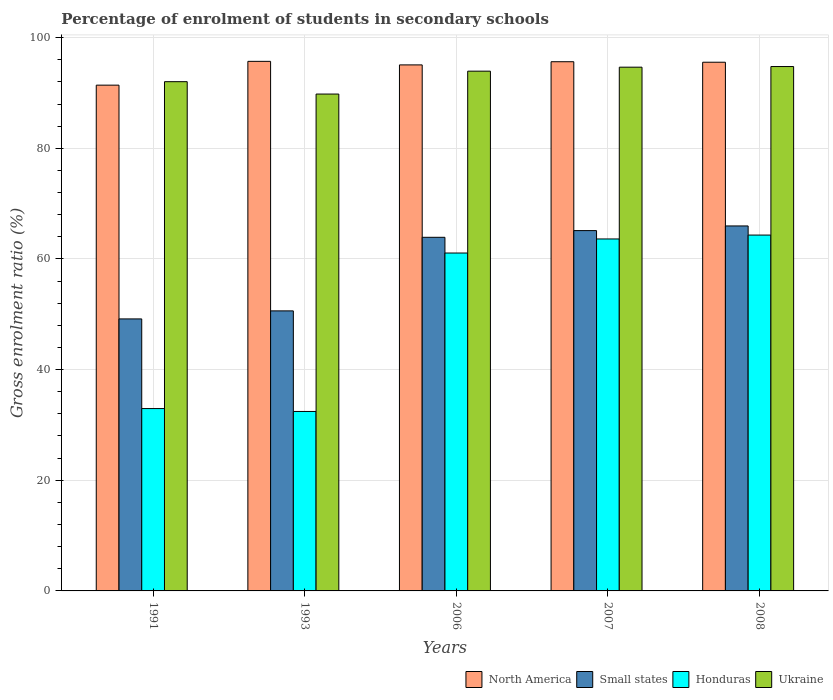How many bars are there on the 5th tick from the left?
Give a very brief answer. 4. What is the percentage of students enrolled in secondary schools in Ukraine in 2007?
Your answer should be compact. 94.66. Across all years, what is the maximum percentage of students enrolled in secondary schools in Small states?
Keep it short and to the point. 65.96. Across all years, what is the minimum percentage of students enrolled in secondary schools in Ukraine?
Keep it short and to the point. 89.8. In which year was the percentage of students enrolled in secondary schools in Small states maximum?
Keep it short and to the point. 2008. In which year was the percentage of students enrolled in secondary schools in North America minimum?
Provide a short and direct response. 1991. What is the total percentage of students enrolled in secondary schools in North America in the graph?
Provide a short and direct response. 473.38. What is the difference between the percentage of students enrolled in secondary schools in Small states in 2006 and that in 2007?
Offer a very short reply. -1.21. What is the difference between the percentage of students enrolled in secondary schools in Honduras in 2007 and the percentage of students enrolled in secondary schools in Ukraine in 2006?
Your answer should be compact. -30.33. What is the average percentage of students enrolled in secondary schools in Honduras per year?
Your response must be concise. 50.88. In the year 2006, what is the difference between the percentage of students enrolled in secondary schools in Ukraine and percentage of students enrolled in secondary schools in Small states?
Make the answer very short. 30.03. What is the ratio of the percentage of students enrolled in secondary schools in North America in 1991 to that in 2007?
Your response must be concise. 0.96. Is the percentage of students enrolled in secondary schools in Honduras in 2006 less than that in 2007?
Ensure brevity in your answer.  Yes. Is the difference between the percentage of students enrolled in secondary schools in Ukraine in 2007 and 2008 greater than the difference between the percentage of students enrolled in secondary schools in Small states in 2007 and 2008?
Provide a succinct answer. Yes. What is the difference between the highest and the second highest percentage of students enrolled in secondary schools in North America?
Your answer should be compact. 0.07. What is the difference between the highest and the lowest percentage of students enrolled in secondary schools in Small states?
Give a very brief answer. 16.8. Is it the case that in every year, the sum of the percentage of students enrolled in secondary schools in Honduras and percentage of students enrolled in secondary schools in Small states is greater than the sum of percentage of students enrolled in secondary schools in North America and percentage of students enrolled in secondary schools in Ukraine?
Give a very brief answer. No. What does the 4th bar from the left in 2007 represents?
Provide a short and direct response. Ukraine. What does the 3rd bar from the right in 2007 represents?
Make the answer very short. Small states. What is the difference between two consecutive major ticks on the Y-axis?
Your answer should be very brief. 20. How are the legend labels stacked?
Your answer should be compact. Horizontal. What is the title of the graph?
Ensure brevity in your answer.  Percentage of enrolment of students in secondary schools. What is the label or title of the X-axis?
Offer a very short reply. Years. What is the Gross enrolment ratio (%) of North America in 1991?
Ensure brevity in your answer.  91.41. What is the Gross enrolment ratio (%) in Small states in 1991?
Provide a succinct answer. 49.16. What is the Gross enrolment ratio (%) in Honduras in 1991?
Ensure brevity in your answer.  32.96. What is the Gross enrolment ratio (%) in Ukraine in 1991?
Give a very brief answer. 92.04. What is the Gross enrolment ratio (%) in North America in 1993?
Give a very brief answer. 95.71. What is the Gross enrolment ratio (%) of Small states in 1993?
Provide a succinct answer. 50.61. What is the Gross enrolment ratio (%) in Honduras in 1993?
Provide a succinct answer. 32.44. What is the Gross enrolment ratio (%) of Ukraine in 1993?
Provide a succinct answer. 89.8. What is the Gross enrolment ratio (%) of North America in 2006?
Provide a succinct answer. 95.07. What is the Gross enrolment ratio (%) in Small states in 2006?
Your answer should be compact. 63.91. What is the Gross enrolment ratio (%) in Honduras in 2006?
Offer a very short reply. 61.07. What is the Gross enrolment ratio (%) of Ukraine in 2006?
Keep it short and to the point. 93.94. What is the Gross enrolment ratio (%) in North America in 2007?
Offer a terse response. 95.64. What is the Gross enrolment ratio (%) of Small states in 2007?
Keep it short and to the point. 65.12. What is the Gross enrolment ratio (%) in Honduras in 2007?
Provide a short and direct response. 63.61. What is the Gross enrolment ratio (%) of Ukraine in 2007?
Your answer should be very brief. 94.66. What is the Gross enrolment ratio (%) of North America in 2008?
Keep it short and to the point. 95.55. What is the Gross enrolment ratio (%) of Small states in 2008?
Offer a very short reply. 65.96. What is the Gross enrolment ratio (%) in Honduras in 2008?
Give a very brief answer. 64.31. What is the Gross enrolment ratio (%) of Ukraine in 2008?
Your answer should be very brief. 94.77. Across all years, what is the maximum Gross enrolment ratio (%) of North America?
Provide a succinct answer. 95.71. Across all years, what is the maximum Gross enrolment ratio (%) in Small states?
Make the answer very short. 65.96. Across all years, what is the maximum Gross enrolment ratio (%) in Honduras?
Make the answer very short. 64.31. Across all years, what is the maximum Gross enrolment ratio (%) of Ukraine?
Your answer should be compact. 94.77. Across all years, what is the minimum Gross enrolment ratio (%) of North America?
Make the answer very short. 91.41. Across all years, what is the minimum Gross enrolment ratio (%) in Small states?
Ensure brevity in your answer.  49.16. Across all years, what is the minimum Gross enrolment ratio (%) of Honduras?
Provide a succinct answer. 32.44. Across all years, what is the minimum Gross enrolment ratio (%) in Ukraine?
Give a very brief answer. 89.8. What is the total Gross enrolment ratio (%) in North America in the graph?
Ensure brevity in your answer.  473.38. What is the total Gross enrolment ratio (%) of Small states in the graph?
Provide a succinct answer. 294.77. What is the total Gross enrolment ratio (%) in Honduras in the graph?
Provide a short and direct response. 254.38. What is the total Gross enrolment ratio (%) of Ukraine in the graph?
Your answer should be compact. 465.2. What is the difference between the Gross enrolment ratio (%) in North America in 1991 and that in 1993?
Provide a succinct answer. -4.3. What is the difference between the Gross enrolment ratio (%) in Small states in 1991 and that in 1993?
Make the answer very short. -1.45. What is the difference between the Gross enrolment ratio (%) in Honduras in 1991 and that in 1993?
Provide a short and direct response. 0.52. What is the difference between the Gross enrolment ratio (%) in Ukraine in 1991 and that in 1993?
Your answer should be compact. 2.24. What is the difference between the Gross enrolment ratio (%) in North America in 1991 and that in 2006?
Provide a short and direct response. -3.66. What is the difference between the Gross enrolment ratio (%) of Small states in 1991 and that in 2006?
Ensure brevity in your answer.  -14.75. What is the difference between the Gross enrolment ratio (%) of Honduras in 1991 and that in 2006?
Offer a very short reply. -28.11. What is the difference between the Gross enrolment ratio (%) in Ukraine in 1991 and that in 2006?
Offer a terse response. -1.9. What is the difference between the Gross enrolment ratio (%) in North America in 1991 and that in 2007?
Your answer should be very brief. -4.23. What is the difference between the Gross enrolment ratio (%) in Small states in 1991 and that in 2007?
Give a very brief answer. -15.96. What is the difference between the Gross enrolment ratio (%) in Honduras in 1991 and that in 2007?
Make the answer very short. -30.65. What is the difference between the Gross enrolment ratio (%) of Ukraine in 1991 and that in 2007?
Keep it short and to the point. -2.62. What is the difference between the Gross enrolment ratio (%) of North America in 1991 and that in 2008?
Offer a terse response. -4.14. What is the difference between the Gross enrolment ratio (%) in Small states in 1991 and that in 2008?
Your response must be concise. -16.8. What is the difference between the Gross enrolment ratio (%) of Honduras in 1991 and that in 2008?
Your response must be concise. -31.36. What is the difference between the Gross enrolment ratio (%) of Ukraine in 1991 and that in 2008?
Make the answer very short. -2.74. What is the difference between the Gross enrolment ratio (%) of North America in 1993 and that in 2006?
Provide a succinct answer. 0.64. What is the difference between the Gross enrolment ratio (%) of Small states in 1993 and that in 2006?
Provide a short and direct response. -13.3. What is the difference between the Gross enrolment ratio (%) of Honduras in 1993 and that in 2006?
Your answer should be compact. -28.63. What is the difference between the Gross enrolment ratio (%) in Ukraine in 1993 and that in 2006?
Your answer should be compact. -4.14. What is the difference between the Gross enrolment ratio (%) in North America in 1993 and that in 2007?
Ensure brevity in your answer.  0.07. What is the difference between the Gross enrolment ratio (%) in Small states in 1993 and that in 2007?
Give a very brief answer. -14.51. What is the difference between the Gross enrolment ratio (%) in Honduras in 1993 and that in 2007?
Your answer should be compact. -31.18. What is the difference between the Gross enrolment ratio (%) of Ukraine in 1993 and that in 2007?
Keep it short and to the point. -4.86. What is the difference between the Gross enrolment ratio (%) in North America in 1993 and that in 2008?
Offer a terse response. 0.16. What is the difference between the Gross enrolment ratio (%) of Small states in 1993 and that in 2008?
Provide a succinct answer. -15.35. What is the difference between the Gross enrolment ratio (%) of Honduras in 1993 and that in 2008?
Make the answer very short. -31.88. What is the difference between the Gross enrolment ratio (%) of Ukraine in 1993 and that in 2008?
Make the answer very short. -4.97. What is the difference between the Gross enrolment ratio (%) in North America in 2006 and that in 2007?
Make the answer very short. -0.57. What is the difference between the Gross enrolment ratio (%) in Small states in 2006 and that in 2007?
Give a very brief answer. -1.21. What is the difference between the Gross enrolment ratio (%) in Honduras in 2006 and that in 2007?
Your answer should be very brief. -2.54. What is the difference between the Gross enrolment ratio (%) in Ukraine in 2006 and that in 2007?
Ensure brevity in your answer.  -0.72. What is the difference between the Gross enrolment ratio (%) of North America in 2006 and that in 2008?
Provide a succinct answer. -0.48. What is the difference between the Gross enrolment ratio (%) in Small states in 2006 and that in 2008?
Ensure brevity in your answer.  -2.05. What is the difference between the Gross enrolment ratio (%) of Honduras in 2006 and that in 2008?
Make the answer very short. -3.25. What is the difference between the Gross enrolment ratio (%) of Ukraine in 2006 and that in 2008?
Give a very brief answer. -0.83. What is the difference between the Gross enrolment ratio (%) of North America in 2007 and that in 2008?
Keep it short and to the point. 0.09. What is the difference between the Gross enrolment ratio (%) in Small states in 2007 and that in 2008?
Ensure brevity in your answer.  -0.84. What is the difference between the Gross enrolment ratio (%) in Honduras in 2007 and that in 2008?
Keep it short and to the point. -0.7. What is the difference between the Gross enrolment ratio (%) in Ukraine in 2007 and that in 2008?
Your response must be concise. -0.12. What is the difference between the Gross enrolment ratio (%) of North America in 1991 and the Gross enrolment ratio (%) of Small states in 1993?
Make the answer very short. 40.8. What is the difference between the Gross enrolment ratio (%) of North America in 1991 and the Gross enrolment ratio (%) of Honduras in 1993?
Make the answer very short. 58.97. What is the difference between the Gross enrolment ratio (%) in North America in 1991 and the Gross enrolment ratio (%) in Ukraine in 1993?
Give a very brief answer. 1.61. What is the difference between the Gross enrolment ratio (%) in Small states in 1991 and the Gross enrolment ratio (%) in Honduras in 1993?
Make the answer very short. 16.73. What is the difference between the Gross enrolment ratio (%) in Small states in 1991 and the Gross enrolment ratio (%) in Ukraine in 1993?
Your response must be concise. -40.64. What is the difference between the Gross enrolment ratio (%) of Honduras in 1991 and the Gross enrolment ratio (%) of Ukraine in 1993?
Offer a very short reply. -56.84. What is the difference between the Gross enrolment ratio (%) in North America in 1991 and the Gross enrolment ratio (%) in Small states in 2006?
Your answer should be very brief. 27.5. What is the difference between the Gross enrolment ratio (%) in North America in 1991 and the Gross enrolment ratio (%) in Honduras in 2006?
Provide a short and direct response. 30.34. What is the difference between the Gross enrolment ratio (%) in North America in 1991 and the Gross enrolment ratio (%) in Ukraine in 2006?
Ensure brevity in your answer.  -2.53. What is the difference between the Gross enrolment ratio (%) in Small states in 1991 and the Gross enrolment ratio (%) in Honduras in 2006?
Your answer should be compact. -11.91. What is the difference between the Gross enrolment ratio (%) of Small states in 1991 and the Gross enrolment ratio (%) of Ukraine in 2006?
Ensure brevity in your answer.  -44.78. What is the difference between the Gross enrolment ratio (%) in Honduras in 1991 and the Gross enrolment ratio (%) in Ukraine in 2006?
Offer a very short reply. -60.98. What is the difference between the Gross enrolment ratio (%) in North America in 1991 and the Gross enrolment ratio (%) in Small states in 2007?
Ensure brevity in your answer.  26.29. What is the difference between the Gross enrolment ratio (%) in North America in 1991 and the Gross enrolment ratio (%) in Honduras in 2007?
Give a very brief answer. 27.8. What is the difference between the Gross enrolment ratio (%) in North America in 1991 and the Gross enrolment ratio (%) in Ukraine in 2007?
Offer a very short reply. -3.25. What is the difference between the Gross enrolment ratio (%) in Small states in 1991 and the Gross enrolment ratio (%) in Honduras in 2007?
Provide a short and direct response. -14.45. What is the difference between the Gross enrolment ratio (%) of Small states in 1991 and the Gross enrolment ratio (%) of Ukraine in 2007?
Make the answer very short. -45.5. What is the difference between the Gross enrolment ratio (%) in Honduras in 1991 and the Gross enrolment ratio (%) in Ukraine in 2007?
Provide a succinct answer. -61.7. What is the difference between the Gross enrolment ratio (%) of North America in 1991 and the Gross enrolment ratio (%) of Small states in 2008?
Offer a very short reply. 25.45. What is the difference between the Gross enrolment ratio (%) of North America in 1991 and the Gross enrolment ratio (%) of Honduras in 2008?
Make the answer very short. 27.09. What is the difference between the Gross enrolment ratio (%) in North America in 1991 and the Gross enrolment ratio (%) in Ukraine in 2008?
Ensure brevity in your answer.  -3.36. What is the difference between the Gross enrolment ratio (%) of Small states in 1991 and the Gross enrolment ratio (%) of Honduras in 2008?
Provide a succinct answer. -15.15. What is the difference between the Gross enrolment ratio (%) of Small states in 1991 and the Gross enrolment ratio (%) of Ukraine in 2008?
Keep it short and to the point. -45.61. What is the difference between the Gross enrolment ratio (%) in Honduras in 1991 and the Gross enrolment ratio (%) in Ukraine in 2008?
Your response must be concise. -61.82. What is the difference between the Gross enrolment ratio (%) of North America in 1993 and the Gross enrolment ratio (%) of Small states in 2006?
Ensure brevity in your answer.  31.8. What is the difference between the Gross enrolment ratio (%) in North America in 1993 and the Gross enrolment ratio (%) in Honduras in 2006?
Your answer should be very brief. 34.64. What is the difference between the Gross enrolment ratio (%) in North America in 1993 and the Gross enrolment ratio (%) in Ukraine in 2006?
Offer a terse response. 1.77. What is the difference between the Gross enrolment ratio (%) of Small states in 1993 and the Gross enrolment ratio (%) of Honduras in 2006?
Make the answer very short. -10.46. What is the difference between the Gross enrolment ratio (%) in Small states in 1993 and the Gross enrolment ratio (%) in Ukraine in 2006?
Make the answer very short. -43.33. What is the difference between the Gross enrolment ratio (%) of Honduras in 1993 and the Gross enrolment ratio (%) of Ukraine in 2006?
Provide a short and direct response. -61.5. What is the difference between the Gross enrolment ratio (%) of North America in 1993 and the Gross enrolment ratio (%) of Small states in 2007?
Give a very brief answer. 30.59. What is the difference between the Gross enrolment ratio (%) in North America in 1993 and the Gross enrolment ratio (%) in Honduras in 2007?
Offer a terse response. 32.1. What is the difference between the Gross enrolment ratio (%) in North America in 1993 and the Gross enrolment ratio (%) in Ukraine in 2007?
Provide a succinct answer. 1.05. What is the difference between the Gross enrolment ratio (%) of Small states in 1993 and the Gross enrolment ratio (%) of Honduras in 2007?
Your answer should be very brief. -13. What is the difference between the Gross enrolment ratio (%) in Small states in 1993 and the Gross enrolment ratio (%) in Ukraine in 2007?
Your answer should be compact. -44.04. What is the difference between the Gross enrolment ratio (%) of Honduras in 1993 and the Gross enrolment ratio (%) of Ukraine in 2007?
Give a very brief answer. -62.22. What is the difference between the Gross enrolment ratio (%) of North America in 1993 and the Gross enrolment ratio (%) of Small states in 2008?
Your response must be concise. 29.75. What is the difference between the Gross enrolment ratio (%) in North America in 1993 and the Gross enrolment ratio (%) in Honduras in 2008?
Provide a succinct answer. 31.4. What is the difference between the Gross enrolment ratio (%) in North America in 1993 and the Gross enrolment ratio (%) in Ukraine in 2008?
Provide a short and direct response. 0.94. What is the difference between the Gross enrolment ratio (%) of Small states in 1993 and the Gross enrolment ratio (%) of Honduras in 2008?
Keep it short and to the point. -13.7. What is the difference between the Gross enrolment ratio (%) of Small states in 1993 and the Gross enrolment ratio (%) of Ukraine in 2008?
Ensure brevity in your answer.  -44.16. What is the difference between the Gross enrolment ratio (%) of Honduras in 1993 and the Gross enrolment ratio (%) of Ukraine in 2008?
Offer a very short reply. -62.34. What is the difference between the Gross enrolment ratio (%) in North America in 2006 and the Gross enrolment ratio (%) in Small states in 2007?
Your answer should be very brief. 29.95. What is the difference between the Gross enrolment ratio (%) in North America in 2006 and the Gross enrolment ratio (%) in Honduras in 2007?
Offer a terse response. 31.46. What is the difference between the Gross enrolment ratio (%) in North America in 2006 and the Gross enrolment ratio (%) in Ukraine in 2007?
Offer a terse response. 0.41. What is the difference between the Gross enrolment ratio (%) of Small states in 2006 and the Gross enrolment ratio (%) of Honduras in 2007?
Give a very brief answer. 0.3. What is the difference between the Gross enrolment ratio (%) in Small states in 2006 and the Gross enrolment ratio (%) in Ukraine in 2007?
Offer a terse response. -30.75. What is the difference between the Gross enrolment ratio (%) in Honduras in 2006 and the Gross enrolment ratio (%) in Ukraine in 2007?
Make the answer very short. -33.59. What is the difference between the Gross enrolment ratio (%) in North America in 2006 and the Gross enrolment ratio (%) in Small states in 2008?
Offer a terse response. 29.11. What is the difference between the Gross enrolment ratio (%) of North America in 2006 and the Gross enrolment ratio (%) of Honduras in 2008?
Your answer should be compact. 30.75. What is the difference between the Gross enrolment ratio (%) of North America in 2006 and the Gross enrolment ratio (%) of Ukraine in 2008?
Your response must be concise. 0.3. What is the difference between the Gross enrolment ratio (%) of Small states in 2006 and the Gross enrolment ratio (%) of Honduras in 2008?
Offer a terse response. -0.4. What is the difference between the Gross enrolment ratio (%) in Small states in 2006 and the Gross enrolment ratio (%) in Ukraine in 2008?
Give a very brief answer. -30.86. What is the difference between the Gross enrolment ratio (%) in Honduras in 2006 and the Gross enrolment ratio (%) in Ukraine in 2008?
Your response must be concise. -33.71. What is the difference between the Gross enrolment ratio (%) in North America in 2007 and the Gross enrolment ratio (%) in Small states in 2008?
Your answer should be very brief. 29.68. What is the difference between the Gross enrolment ratio (%) in North America in 2007 and the Gross enrolment ratio (%) in Honduras in 2008?
Make the answer very short. 31.33. What is the difference between the Gross enrolment ratio (%) of North America in 2007 and the Gross enrolment ratio (%) of Ukraine in 2008?
Keep it short and to the point. 0.87. What is the difference between the Gross enrolment ratio (%) in Small states in 2007 and the Gross enrolment ratio (%) in Honduras in 2008?
Your response must be concise. 0.81. What is the difference between the Gross enrolment ratio (%) of Small states in 2007 and the Gross enrolment ratio (%) of Ukraine in 2008?
Your answer should be compact. -29.65. What is the difference between the Gross enrolment ratio (%) in Honduras in 2007 and the Gross enrolment ratio (%) in Ukraine in 2008?
Offer a very short reply. -31.16. What is the average Gross enrolment ratio (%) of North America per year?
Keep it short and to the point. 94.68. What is the average Gross enrolment ratio (%) in Small states per year?
Give a very brief answer. 58.95. What is the average Gross enrolment ratio (%) of Honduras per year?
Your answer should be compact. 50.88. What is the average Gross enrolment ratio (%) in Ukraine per year?
Your response must be concise. 93.04. In the year 1991, what is the difference between the Gross enrolment ratio (%) of North America and Gross enrolment ratio (%) of Small states?
Your answer should be very brief. 42.25. In the year 1991, what is the difference between the Gross enrolment ratio (%) of North America and Gross enrolment ratio (%) of Honduras?
Keep it short and to the point. 58.45. In the year 1991, what is the difference between the Gross enrolment ratio (%) of North America and Gross enrolment ratio (%) of Ukraine?
Keep it short and to the point. -0.63. In the year 1991, what is the difference between the Gross enrolment ratio (%) in Small states and Gross enrolment ratio (%) in Honduras?
Your answer should be very brief. 16.2. In the year 1991, what is the difference between the Gross enrolment ratio (%) in Small states and Gross enrolment ratio (%) in Ukraine?
Your answer should be very brief. -42.88. In the year 1991, what is the difference between the Gross enrolment ratio (%) in Honduras and Gross enrolment ratio (%) in Ukraine?
Offer a very short reply. -59.08. In the year 1993, what is the difference between the Gross enrolment ratio (%) of North America and Gross enrolment ratio (%) of Small states?
Your answer should be very brief. 45.1. In the year 1993, what is the difference between the Gross enrolment ratio (%) in North America and Gross enrolment ratio (%) in Honduras?
Keep it short and to the point. 63.27. In the year 1993, what is the difference between the Gross enrolment ratio (%) of North America and Gross enrolment ratio (%) of Ukraine?
Offer a terse response. 5.91. In the year 1993, what is the difference between the Gross enrolment ratio (%) of Small states and Gross enrolment ratio (%) of Honduras?
Provide a succinct answer. 18.18. In the year 1993, what is the difference between the Gross enrolment ratio (%) of Small states and Gross enrolment ratio (%) of Ukraine?
Offer a terse response. -39.19. In the year 1993, what is the difference between the Gross enrolment ratio (%) in Honduras and Gross enrolment ratio (%) in Ukraine?
Your answer should be compact. -57.37. In the year 2006, what is the difference between the Gross enrolment ratio (%) in North America and Gross enrolment ratio (%) in Small states?
Provide a succinct answer. 31.16. In the year 2006, what is the difference between the Gross enrolment ratio (%) of North America and Gross enrolment ratio (%) of Honduras?
Provide a succinct answer. 34. In the year 2006, what is the difference between the Gross enrolment ratio (%) of North America and Gross enrolment ratio (%) of Ukraine?
Provide a short and direct response. 1.13. In the year 2006, what is the difference between the Gross enrolment ratio (%) of Small states and Gross enrolment ratio (%) of Honduras?
Give a very brief answer. 2.84. In the year 2006, what is the difference between the Gross enrolment ratio (%) in Small states and Gross enrolment ratio (%) in Ukraine?
Keep it short and to the point. -30.03. In the year 2006, what is the difference between the Gross enrolment ratio (%) of Honduras and Gross enrolment ratio (%) of Ukraine?
Your answer should be compact. -32.87. In the year 2007, what is the difference between the Gross enrolment ratio (%) in North America and Gross enrolment ratio (%) in Small states?
Provide a short and direct response. 30.52. In the year 2007, what is the difference between the Gross enrolment ratio (%) in North America and Gross enrolment ratio (%) in Honduras?
Ensure brevity in your answer.  32.03. In the year 2007, what is the difference between the Gross enrolment ratio (%) in North America and Gross enrolment ratio (%) in Ukraine?
Offer a very short reply. 0.99. In the year 2007, what is the difference between the Gross enrolment ratio (%) of Small states and Gross enrolment ratio (%) of Honduras?
Ensure brevity in your answer.  1.51. In the year 2007, what is the difference between the Gross enrolment ratio (%) of Small states and Gross enrolment ratio (%) of Ukraine?
Your response must be concise. -29.54. In the year 2007, what is the difference between the Gross enrolment ratio (%) of Honduras and Gross enrolment ratio (%) of Ukraine?
Make the answer very short. -31.05. In the year 2008, what is the difference between the Gross enrolment ratio (%) of North America and Gross enrolment ratio (%) of Small states?
Offer a terse response. 29.59. In the year 2008, what is the difference between the Gross enrolment ratio (%) in North America and Gross enrolment ratio (%) in Honduras?
Your answer should be very brief. 31.24. In the year 2008, what is the difference between the Gross enrolment ratio (%) in North America and Gross enrolment ratio (%) in Ukraine?
Ensure brevity in your answer.  0.78. In the year 2008, what is the difference between the Gross enrolment ratio (%) in Small states and Gross enrolment ratio (%) in Honduras?
Your answer should be compact. 1.65. In the year 2008, what is the difference between the Gross enrolment ratio (%) of Small states and Gross enrolment ratio (%) of Ukraine?
Ensure brevity in your answer.  -28.81. In the year 2008, what is the difference between the Gross enrolment ratio (%) of Honduras and Gross enrolment ratio (%) of Ukraine?
Ensure brevity in your answer.  -30.46. What is the ratio of the Gross enrolment ratio (%) in North America in 1991 to that in 1993?
Your response must be concise. 0.96. What is the ratio of the Gross enrolment ratio (%) of Small states in 1991 to that in 1993?
Your answer should be very brief. 0.97. What is the ratio of the Gross enrolment ratio (%) of Honduras in 1991 to that in 1993?
Ensure brevity in your answer.  1.02. What is the ratio of the Gross enrolment ratio (%) in Ukraine in 1991 to that in 1993?
Your answer should be very brief. 1.02. What is the ratio of the Gross enrolment ratio (%) in North America in 1991 to that in 2006?
Give a very brief answer. 0.96. What is the ratio of the Gross enrolment ratio (%) of Small states in 1991 to that in 2006?
Your response must be concise. 0.77. What is the ratio of the Gross enrolment ratio (%) of Honduras in 1991 to that in 2006?
Your answer should be very brief. 0.54. What is the ratio of the Gross enrolment ratio (%) of Ukraine in 1991 to that in 2006?
Keep it short and to the point. 0.98. What is the ratio of the Gross enrolment ratio (%) of North America in 1991 to that in 2007?
Make the answer very short. 0.96. What is the ratio of the Gross enrolment ratio (%) in Small states in 1991 to that in 2007?
Offer a very short reply. 0.75. What is the ratio of the Gross enrolment ratio (%) of Honduras in 1991 to that in 2007?
Offer a terse response. 0.52. What is the ratio of the Gross enrolment ratio (%) in Ukraine in 1991 to that in 2007?
Provide a short and direct response. 0.97. What is the ratio of the Gross enrolment ratio (%) in North America in 1991 to that in 2008?
Your answer should be very brief. 0.96. What is the ratio of the Gross enrolment ratio (%) of Small states in 1991 to that in 2008?
Your answer should be compact. 0.75. What is the ratio of the Gross enrolment ratio (%) of Honduras in 1991 to that in 2008?
Your answer should be compact. 0.51. What is the ratio of the Gross enrolment ratio (%) in Ukraine in 1991 to that in 2008?
Give a very brief answer. 0.97. What is the ratio of the Gross enrolment ratio (%) in Small states in 1993 to that in 2006?
Your answer should be compact. 0.79. What is the ratio of the Gross enrolment ratio (%) of Honduras in 1993 to that in 2006?
Provide a short and direct response. 0.53. What is the ratio of the Gross enrolment ratio (%) of Ukraine in 1993 to that in 2006?
Provide a short and direct response. 0.96. What is the ratio of the Gross enrolment ratio (%) of Small states in 1993 to that in 2007?
Provide a succinct answer. 0.78. What is the ratio of the Gross enrolment ratio (%) of Honduras in 1993 to that in 2007?
Provide a succinct answer. 0.51. What is the ratio of the Gross enrolment ratio (%) of Ukraine in 1993 to that in 2007?
Your answer should be compact. 0.95. What is the ratio of the Gross enrolment ratio (%) in North America in 1993 to that in 2008?
Provide a succinct answer. 1. What is the ratio of the Gross enrolment ratio (%) in Small states in 1993 to that in 2008?
Ensure brevity in your answer.  0.77. What is the ratio of the Gross enrolment ratio (%) in Honduras in 1993 to that in 2008?
Your response must be concise. 0.5. What is the ratio of the Gross enrolment ratio (%) of Ukraine in 1993 to that in 2008?
Keep it short and to the point. 0.95. What is the ratio of the Gross enrolment ratio (%) in North America in 2006 to that in 2007?
Your answer should be very brief. 0.99. What is the ratio of the Gross enrolment ratio (%) of Small states in 2006 to that in 2007?
Your response must be concise. 0.98. What is the ratio of the Gross enrolment ratio (%) in Honduras in 2006 to that in 2007?
Your response must be concise. 0.96. What is the ratio of the Gross enrolment ratio (%) in Ukraine in 2006 to that in 2007?
Offer a very short reply. 0.99. What is the ratio of the Gross enrolment ratio (%) in North America in 2006 to that in 2008?
Your response must be concise. 0.99. What is the ratio of the Gross enrolment ratio (%) in Small states in 2006 to that in 2008?
Provide a short and direct response. 0.97. What is the ratio of the Gross enrolment ratio (%) in Honduras in 2006 to that in 2008?
Offer a terse response. 0.95. What is the ratio of the Gross enrolment ratio (%) of North America in 2007 to that in 2008?
Make the answer very short. 1. What is the ratio of the Gross enrolment ratio (%) in Small states in 2007 to that in 2008?
Provide a succinct answer. 0.99. What is the ratio of the Gross enrolment ratio (%) in Ukraine in 2007 to that in 2008?
Provide a short and direct response. 1. What is the difference between the highest and the second highest Gross enrolment ratio (%) in North America?
Your response must be concise. 0.07. What is the difference between the highest and the second highest Gross enrolment ratio (%) of Small states?
Your answer should be very brief. 0.84. What is the difference between the highest and the second highest Gross enrolment ratio (%) in Honduras?
Give a very brief answer. 0.7. What is the difference between the highest and the second highest Gross enrolment ratio (%) in Ukraine?
Your answer should be very brief. 0.12. What is the difference between the highest and the lowest Gross enrolment ratio (%) in North America?
Provide a succinct answer. 4.3. What is the difference between the highest and the lowest Gross enrolment ratio (%) of Small states?
Keep it short and to the point. 16.8. What is the difference between the highest and the lowest Gross enrolment ratio (%) of Honduras?
Offer a very short reply. 31.88. What is the difference between the highest and the lowest Gross enrolment ratio (%) in Ukraine?
Your answer should be very brief. 4.97. 